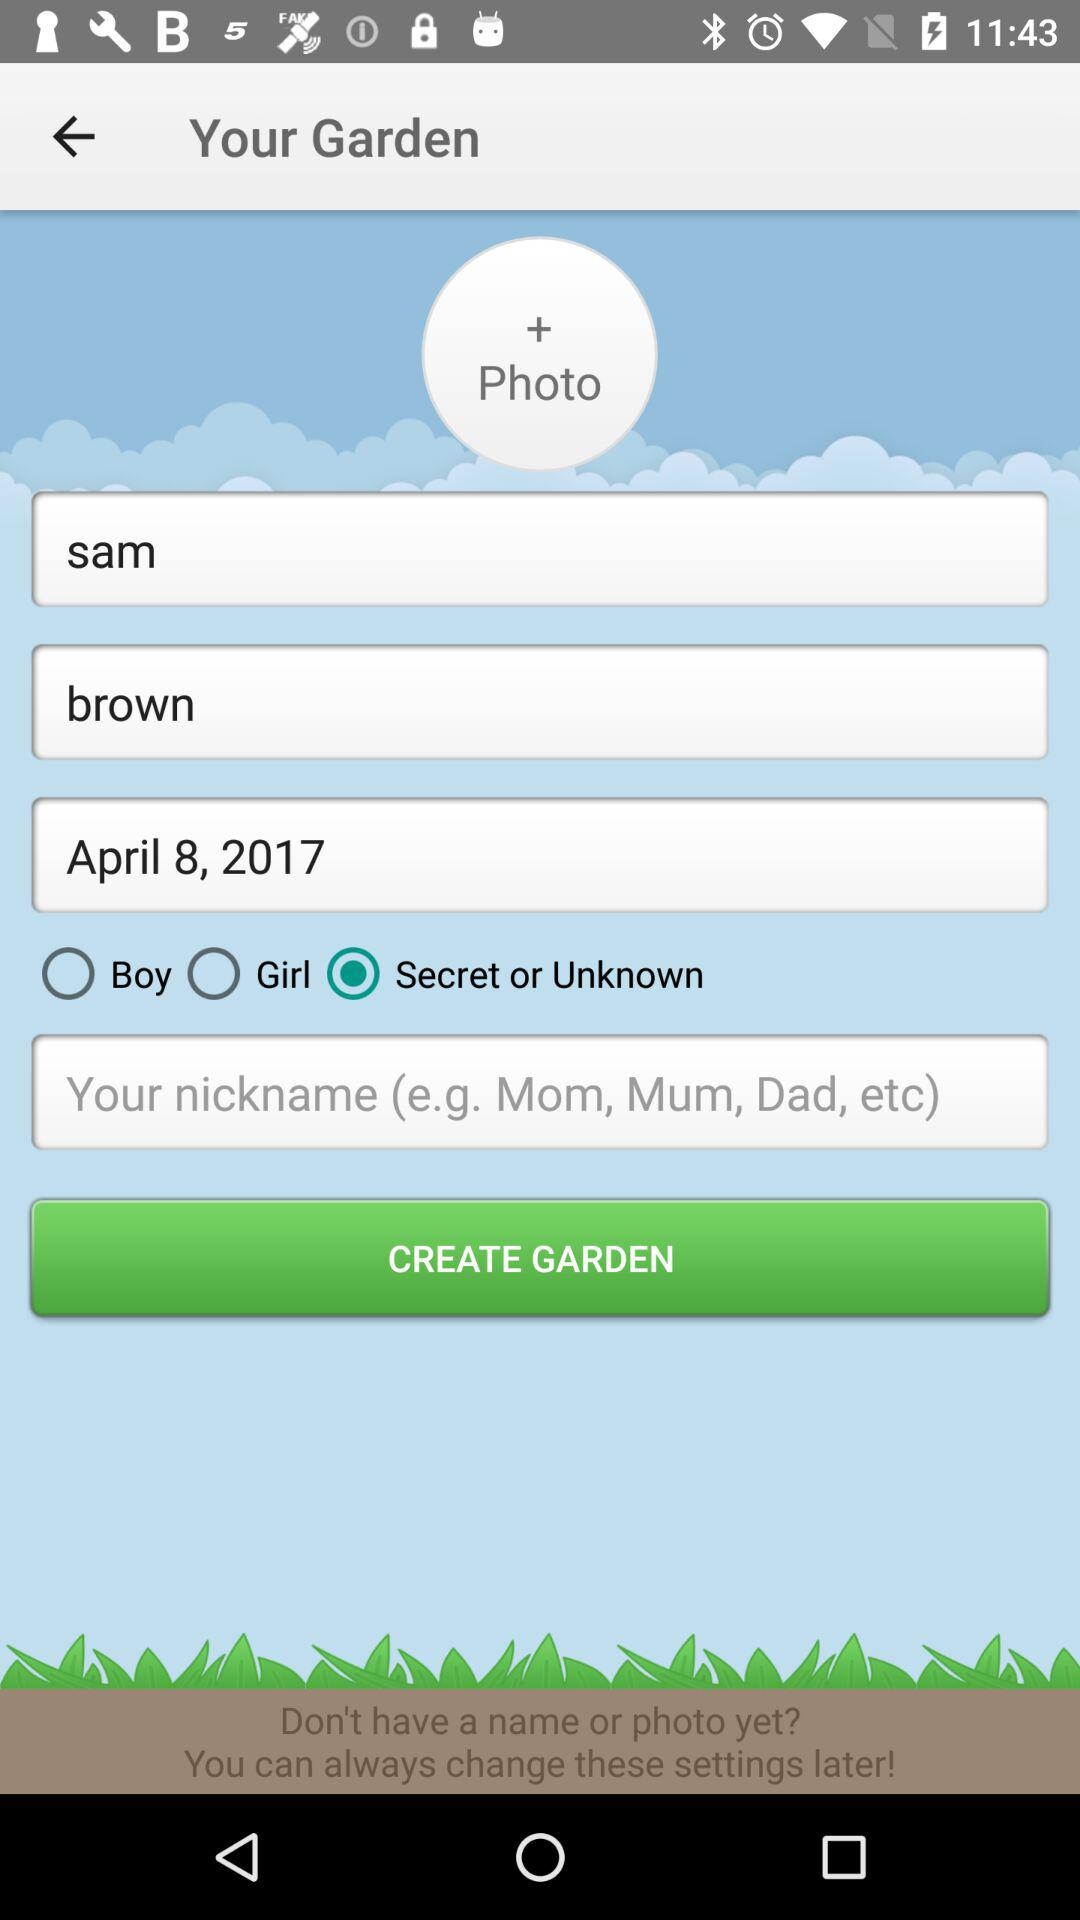How to pronounce his name?
When the provided information is insufficient, respond with <no answer>. <no answer> 